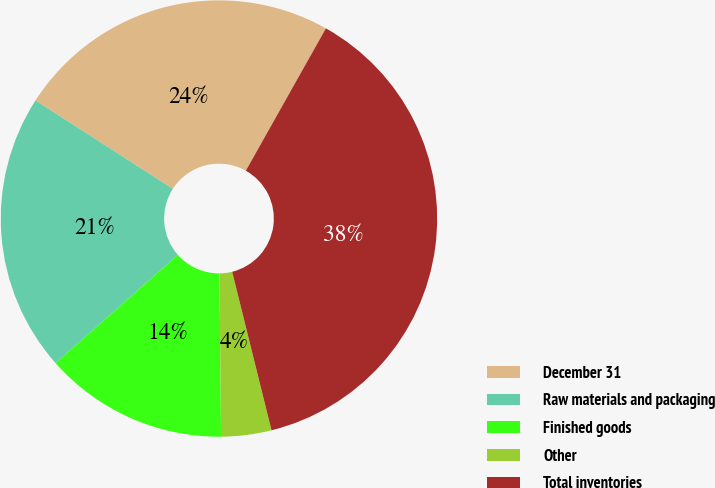Convert chart. <chart><loc_0><loc_0><loc_500><loc_500><pie_chart><fcel>December 31<fcel>Raw materials and packaging<fcel>Finished goods<fcel>Other<fcel>Total inventories<nl><fcel>24.05%<fcel>20.63%<fcel>13.62%<fcel>3.72%<fcel>37.97%<nl></chart> 